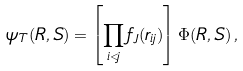<formula> <loc_0><loc_0><loc_500><loc_500>\psi _ { T } ( R , S ) = \left [ \prod _ { i < j } f _ { J } ( r _ { i j } ) \right ] \Phi ( R , S ) \, ,</formula> 